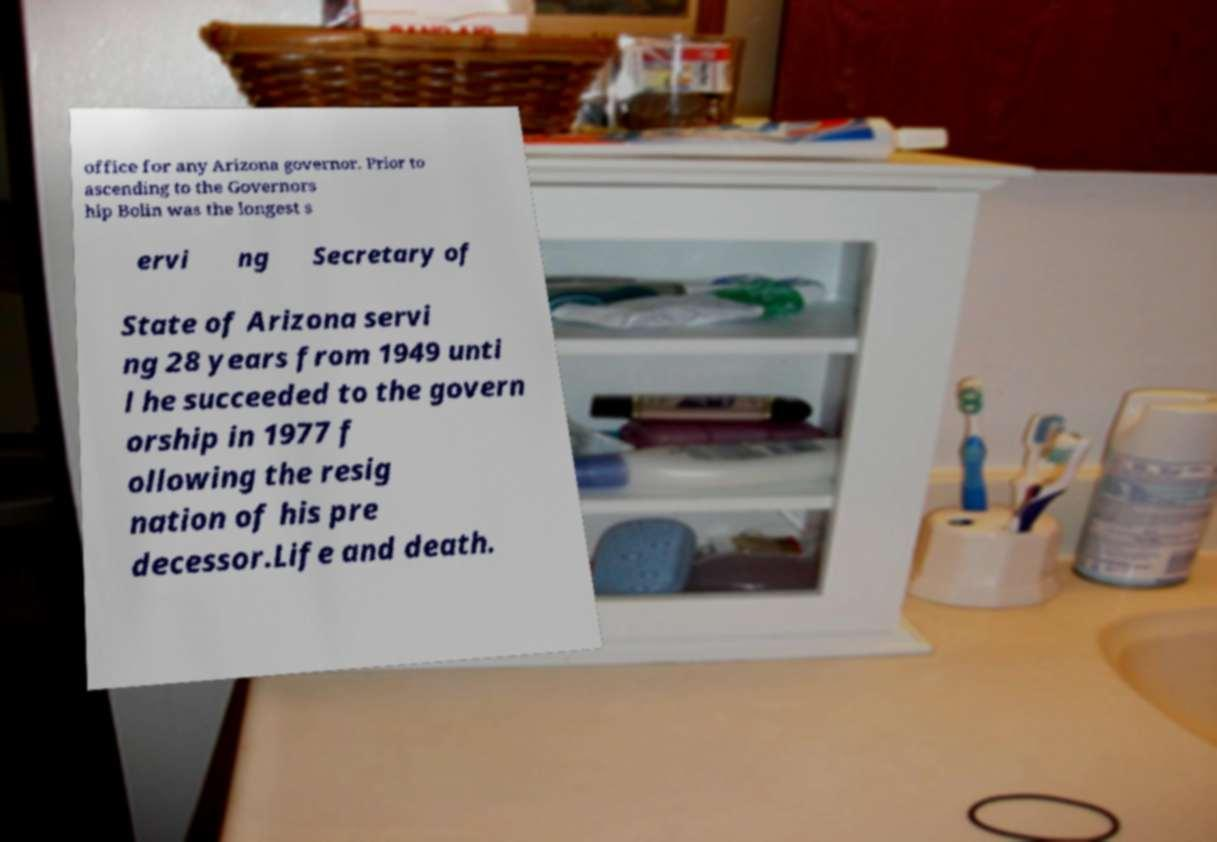For documentation purposes, I need the text within this image transcribed. Could you provide that? office for any Arizona governor. Prior to ascending to the Governors hip Bolin was the longest s ervi ng Secretary of State of Arizona servi ng 28 years from 1949 unti l he succeeded to the govern orship in 1977 f ollowing the resig nation of his pre decessor.Life and death. 